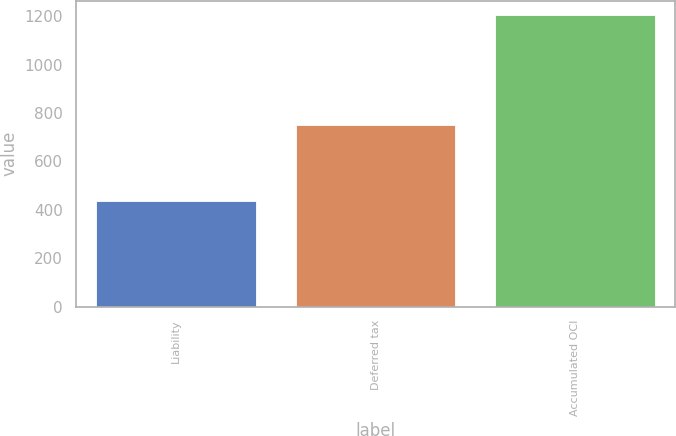Convert chart to OTSL. <chart><loc_0><loc_0><loc_500><loc_500><bar_chart><fcel>Liability<fcel>Deferred tax<fcel>Accumulated OCI<nl><fcel>435<fcel>749<fcel>1204<nl></chart> 